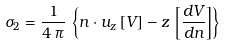Convert formula to latex. <formula><loc_0><loc_0><loc_500><loc_500>\sigma _ { 2 } = \frac { 1 } { 4 \, \pi } \, \left \{ n \cdot u _ { z } \, [ V ] - z \, \left [ \frac { d V } { d n } \right ] \right \}</formula> 